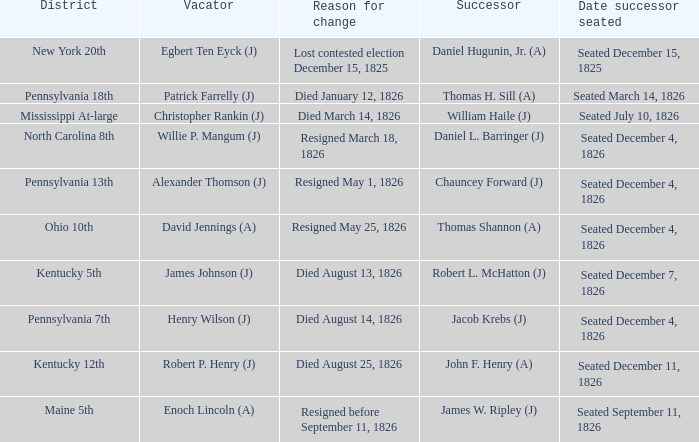Name the reason for change pennsylvania 13th Resigned May 1, 1826. 